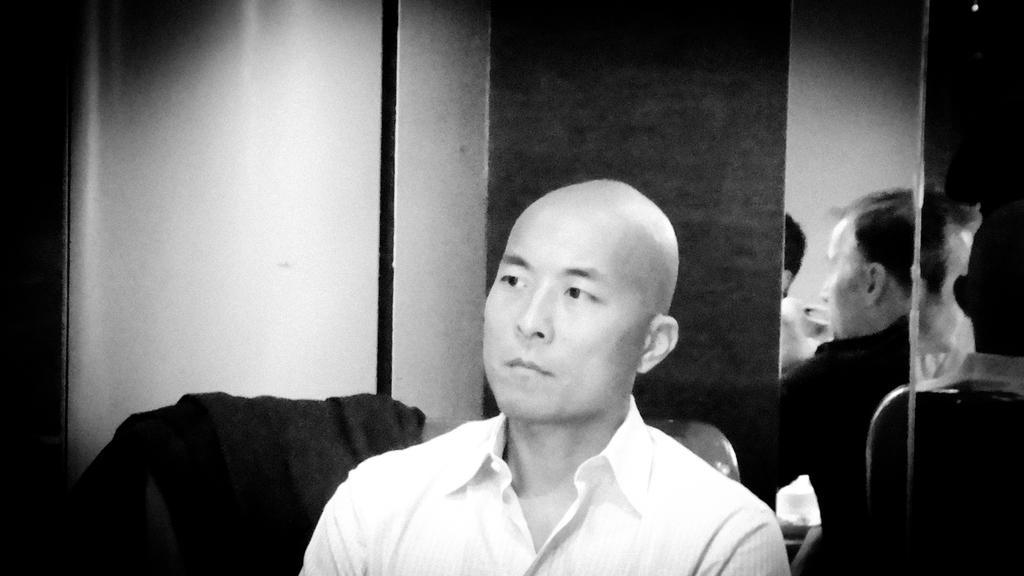Can you describe this image briefly? In this image I can see the black and white picture in which I can see a person wearing white colored shirt is sitting. I can see the black and white colored surface and few persons in the background. 